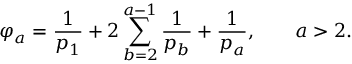<formula> <loc_0><loc_0><loc_500><loc_500>\varphi _ { a } = \frac { 1 } { p _ { 1 } } + 2 \sum _ { b = 2 } ^ { a - 1 } \frac { 1 } { p _ { b } } + \frac { 1 } { p _ { a } } , \quad a > 2 .</formula> 